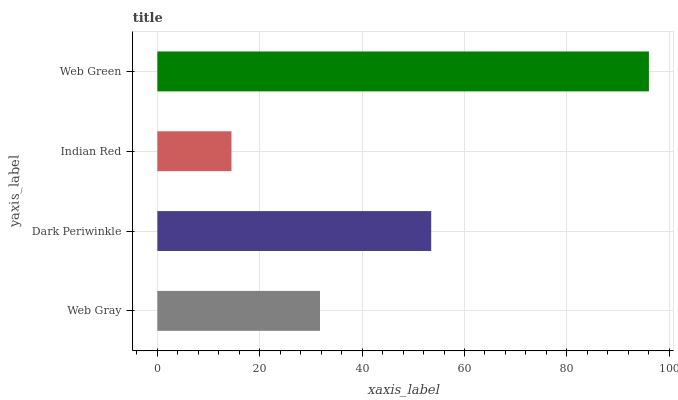Is Indian Red the minimum?
Answer yes or no. Yes. Is Web Green the maximum?
Answer yes or no. Yes. Is Dark Periwinkle the minimum?
Answer yes or no. No. Is Dark Periwinkle the maximum?
Answer yes or no. No. Is Dark Periwinkle greater than Web Gray?
Answer yes or no. Yes. Is Web Gray less than Dark Periwinkle?
Answer yes or no. Yes. Is Web Gray greater than Dark Periwinkle?
Answer yes or no. No. Is Dark Periwinkle less than Web Gray?
Answer yes or no. No. Is Dark Periwinkle the high median?
Answer yes or no. Yes. Is Web Gray the low median?
Answer yes or no. Yes. Is Web Green the high median?
Answer yes or no. No. Is Dark Periwinkle the low median?
Answer yes or no. No. 